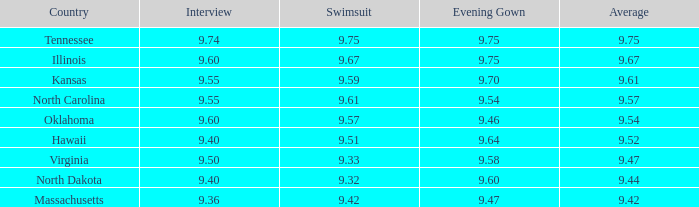What was the average score of the country that had a 9.57 score in the swimsuit category? 9.54. 